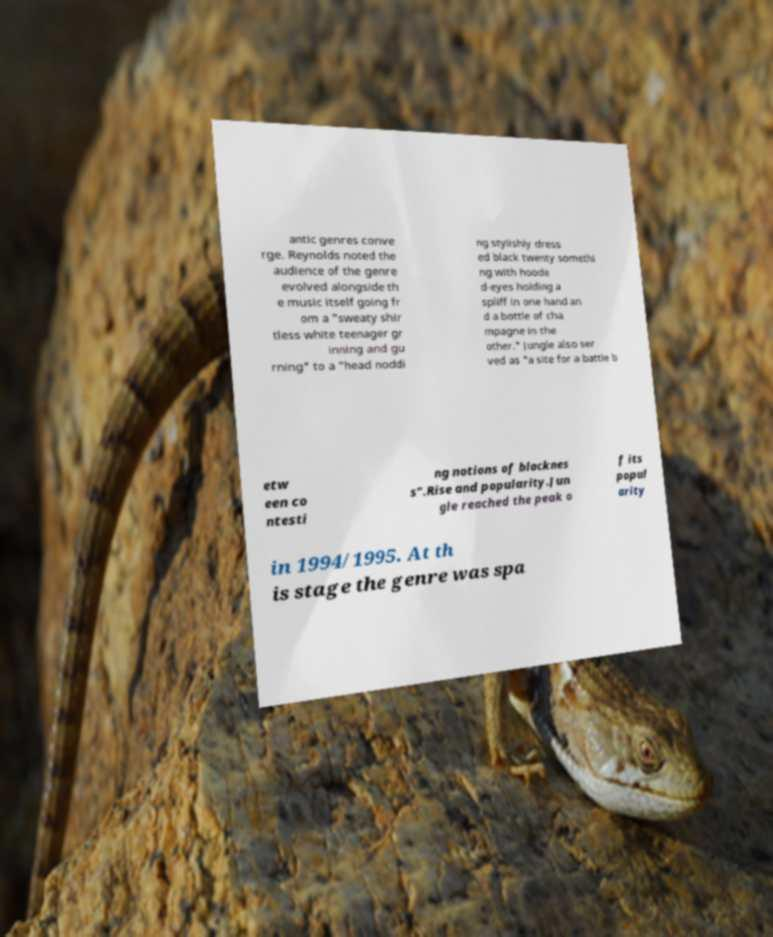Please read and relay the text visible in this image. What does it say? antic genres conve rge. Reynolds noted the audience of the genre evolved alongside th e music itself going fr om a "sweaty shir tless white teenager gr inning and gu rning" to a "head noddi ng stylishly dress ed black twenty somethi ng with hoode d-eyes holding a spliff in one hand an d a bottle of cha mpagne in the other." Jungle also ser ved as "a site for a battle b etw een co ntesti ng notions of blacknes s".Rise and popularity.Jun gle reached the peak o f its popul arity in 1994/1995. At th is stage the genre was spa 